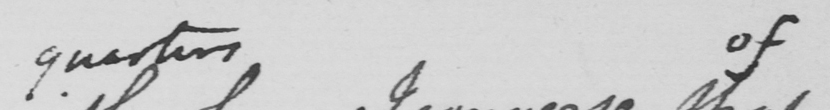Can you read and transcribe this handwriting? quarters of 